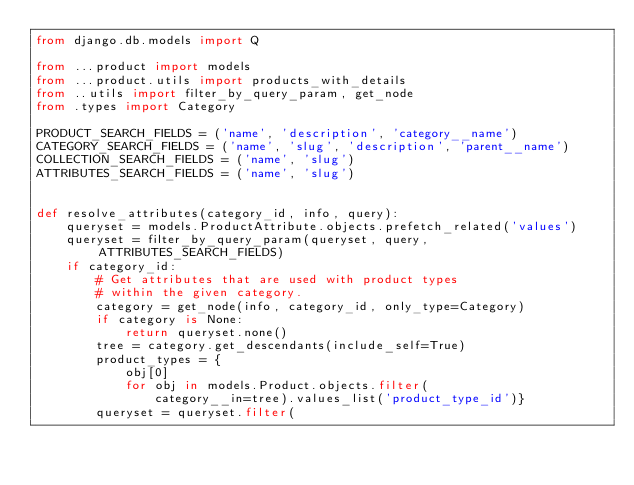Convert code to text. <code><loc_0><loc_0><loc_500><loc_500><_Python_>from django.db.models import Q

from ...product import models
from ...product.utils import products_with_details
from ..utils import filter_by_query_param, get_node
from .types import Category

PRODUCT_SEARCH_FIELDS = ('name', 'description', 'category__name')
CATEGORY_SEARCH_FIELDS = ('name', 'slug', 'description', 'parent__name')
COLLECTION_SEARCH_FIELDS = ('name', 'slug')
ATTRIBUTES_SEARCH_FIELDS = ('name', 'slug')


def resolve_attributes(category_id, info, query):
    queryset = models.ProductAttribute.objects.prefetch_related('values')
    queryset = filter_by_query_param(queryset, query, ATTRIBUTES_SEARCH_FIELDS)
    if category_id:
        # Get attributes that are used with product types
        # within the given category.
        category = get_node(info, category_id, only_type=Category)
        if category is None:
            return queryset.none()
        tree = category.get_descendants(include_self=True)
        product_types = {
            obj[0]
            for obj in models.Product.objects.filter(
                category__in=tree).values_list('product_type_id')}
        queryset = queryset.filter(</code> 